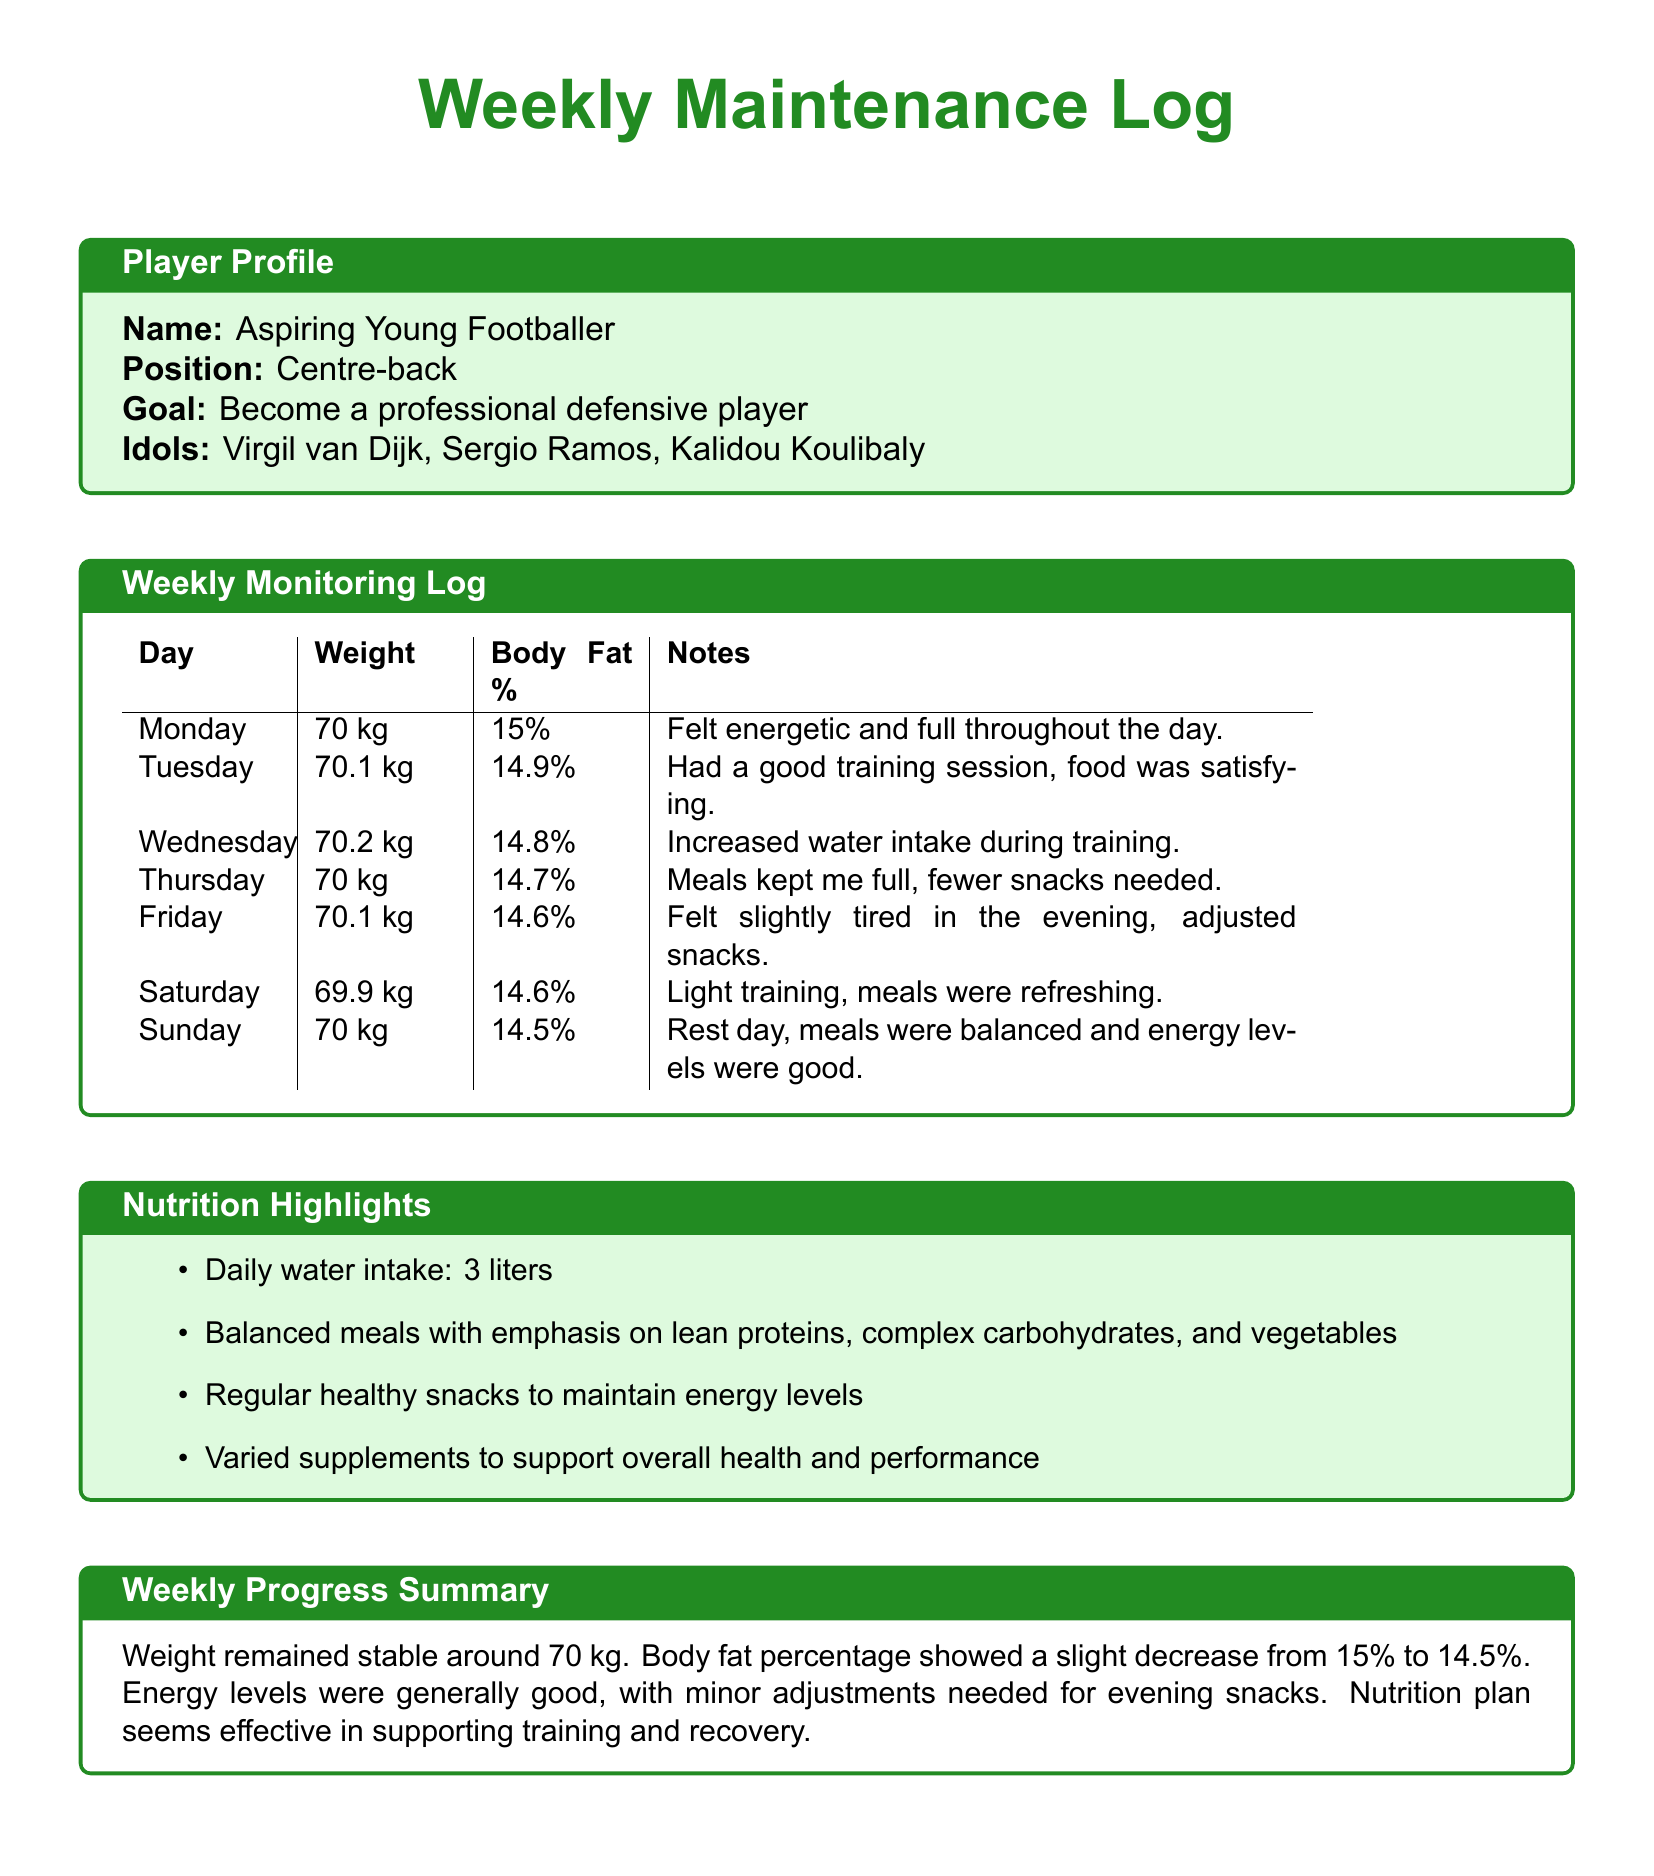What is the player's name? The player's name is explicitly listed in the document under the Player Profile section.
Answer: Aspiring Young Footballer What is the position of the player? The position of the player is stated directly in the Player Profile section.
Answer: Centre-back What was the weight on Thursday? The weight recorded on Thursday can be found in the Weekly Monitoring Log.
Answer: 70 kg What is the body fat percentage on Sunday? The body fat percentage for Sunday is provided in the Weekly Monitoring Log for that day.
Answer: 14.5% What was the player's daily water intake? The daily water intake is highlighted in the Nutrition Highlights section as a specific quantity.
Answer: 3 liters How many days did the player's body fat percentage decrease? By reviewing the body fat percentage across the week, one can determine how many days it declined.
Answer: 5 days What nutritional focus is emphasized in the meals? The Nutrition Highlights state what is particularly emphasized in the meals prepared for the player.
Answer: Lean proteins What was the overall assessment in the Weekly Progress Summary? The overall assessment in the Weekly Progress Summary provides a concise conclusion about the week's progress regarding weight and body fat.
Answer: Effective in supporting training and recovery What adjustment was made on Friday? The adjustment mentioned for Friday is detailed in the Weekly Monitoring Log notes for that day.
Answer: Adjusted snacks 